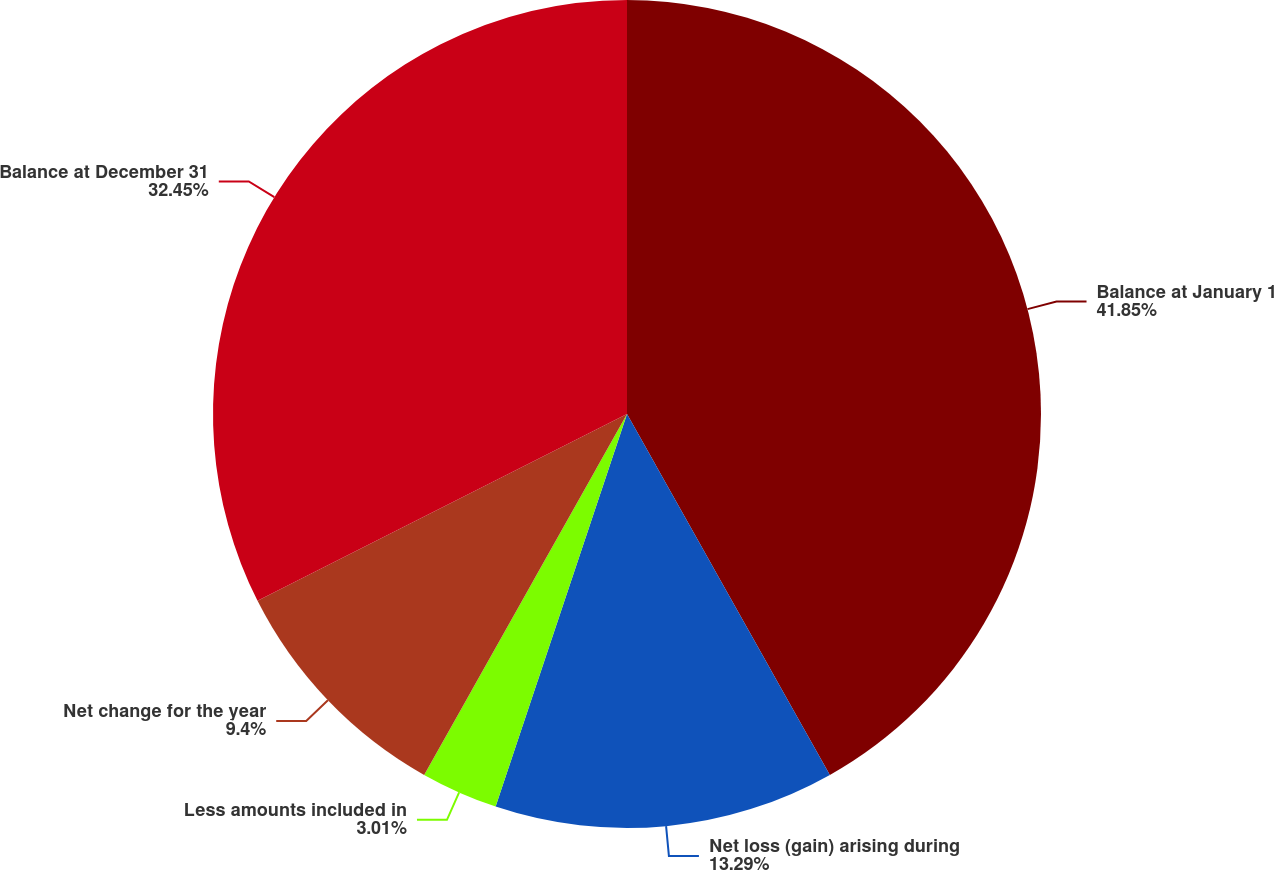Convert chart to OTSL. <chart><loc_0><loc_0><loc_500><loc_500><pie_chart><fcel>Balance at January 1<fcel>Net loss (gain) arising during<fcel>Less amounts included in<fcel>Net change for the year<fcel>Balance at December 31<nl><fcel>41.85%<fcel>13.29%<fcel>3.01%<fcel>9.4%<fcel>32.45%<nl></chart> 